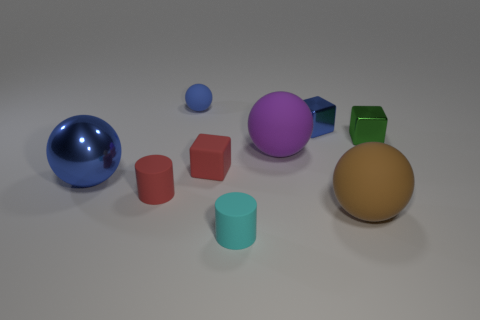Subtract all blue cylinders. How many blue spheres are left? 2 Subtract all shiny cubes. How many cubes are left? 1 Subtract 1 cubes. How many cubes are left? 2 Subtract all yellow spheres. Subtract all cyan cylinders. How many spheres are left? 4 Subtract all large rubber balls. Subtract all small blue shiny things. How many objects are left? 6 Add 8 small blue metal objects. How many small blue metal objects are left? 9 Add 9 red rubber cylinders. How many red rubber cylinders exist? 10 Subtract 0 gray spheres. How many objects are left? 9 Subtract all spheres. How many objects are left? 5 